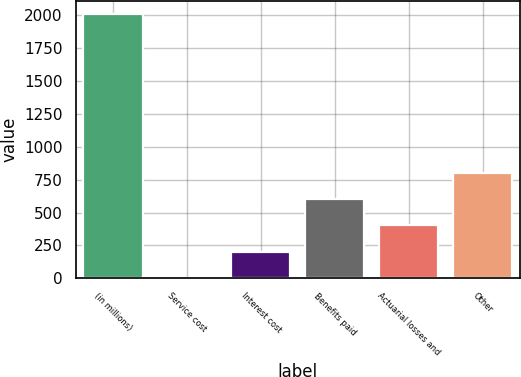<chart> <loc_0><loc_0><loc_500><loc_500><bar_chart><fcel>(in millions)<fcel>Service cost<fcel>Interest cost<fcel>Benefits paid<fcel>Actuarial losses and<fcel>Other<nl><fcel>2011<fcel>1<fcel>202<fcel>604<fcel>403<fcel>805<nl></chart> 